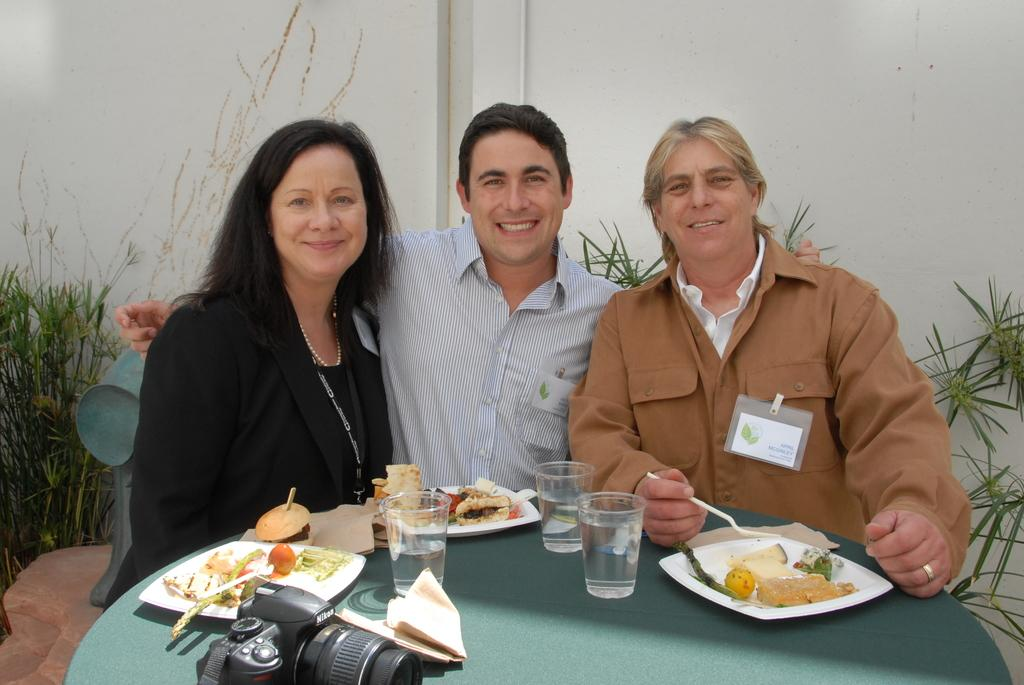How many people are seated in the image? There are three people seated in the image. What is the facial expression of the people in the image? The people are smiling. What can be found on the table in the image? There are plates with food and glasses with water on the table. What object is used for capturing images in the image? There is a camera visible in the image. What type of railway is visible in the image? There is no railway present in the image. What type of juice is being served in the glasses on the table? The glasses on the table contain water, not juice. 